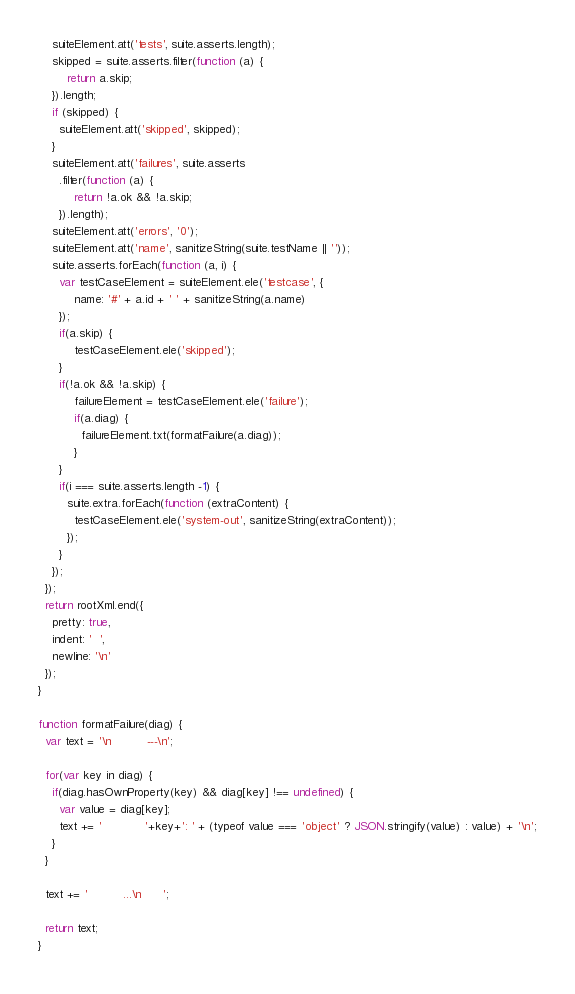Convert code to text. <code><loc_0><loc_0><loc_500><loc_500><_JavaScript_>    suiteElement.att('tests', suite.asserts.length);
    skipped = suite.asserts.filter(function (a) {
        return a.skip;
    }).length;
    if (skipped) {
      suiteElement.att('skipped', skipped);
    }
    suiteElement.att('failures', suite.asserts
      .filter(function (a) {
          return !a.ok && !a.skip;
      }).length);
    suiteElement.att('errors', '0');
    suiteElement.att('name', sanitizeString(suite.testName || ''));
    suite.asserts.forEach(function (a, i) {
      var testCaseElement = suiteElement.ele('testcase', {
          name: '#' + a.id + ' ' + sanitizeString(a.name)
      });
      if(a.skip) {
          testCaseElement.ele('skipped');
      }
      if(!a.ok && !a.skip) {
          failureElement = testCaseElement.ele('failure');
          if(a.diag) {
            failureElement.txt(formatFailure(a.diag));
          }
      }
      if(i === suite.asserts.length -1) {
        suite.extra.forEach(function (extraContent) {
          testCaseElement.ele('system-out', sanitizeString(extraContent));
        });
      }
    });
  });
  return rootXml.end({
    pretty: true,
    indent: '  ',
    newline: '\n'
  });
}

function formatFailure(diag) {
  var text = '\n          ---\n';

  for(var key in diag) {
    if(diag.hasOwnProperty(key) && diag[key] !== undefined) {
      var value = diag[key];
      text += '            '+key+': ' + (typeof value === 'object' ? JSON.stringify(value) : value) + '\n';
    }
  }

  text += '          ...\n      ';

  return text;
}
</code> 